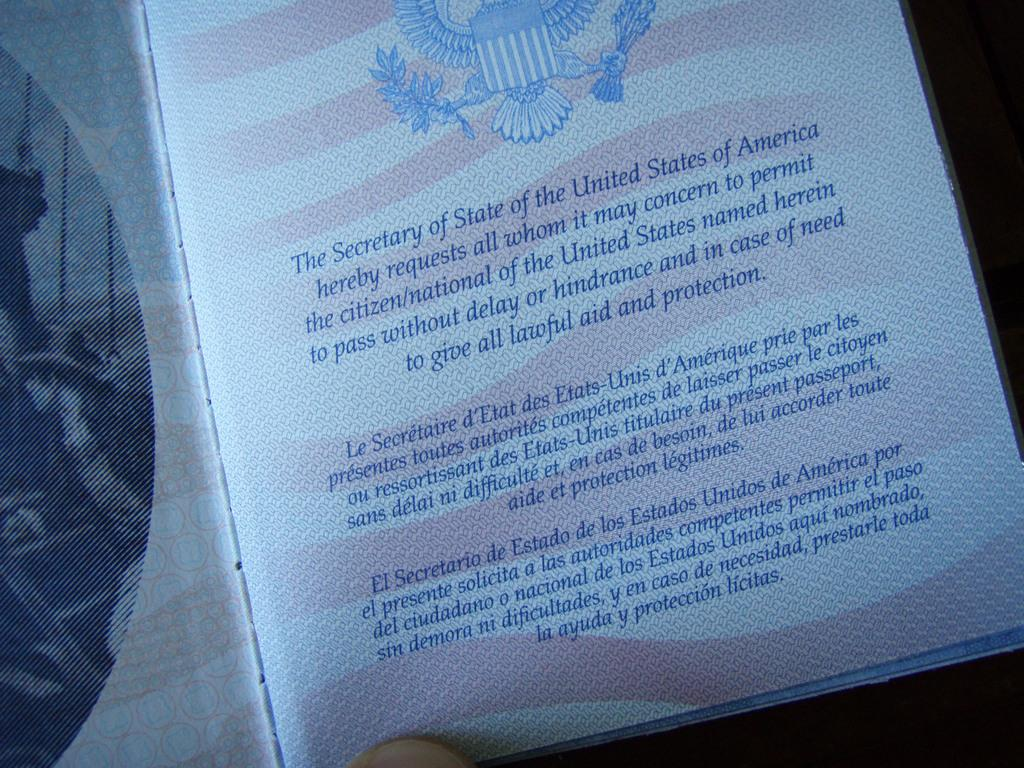<image>
Create a compact narrative representing the image presented. A page in a United States passport where the request from the Secretary of State is written 